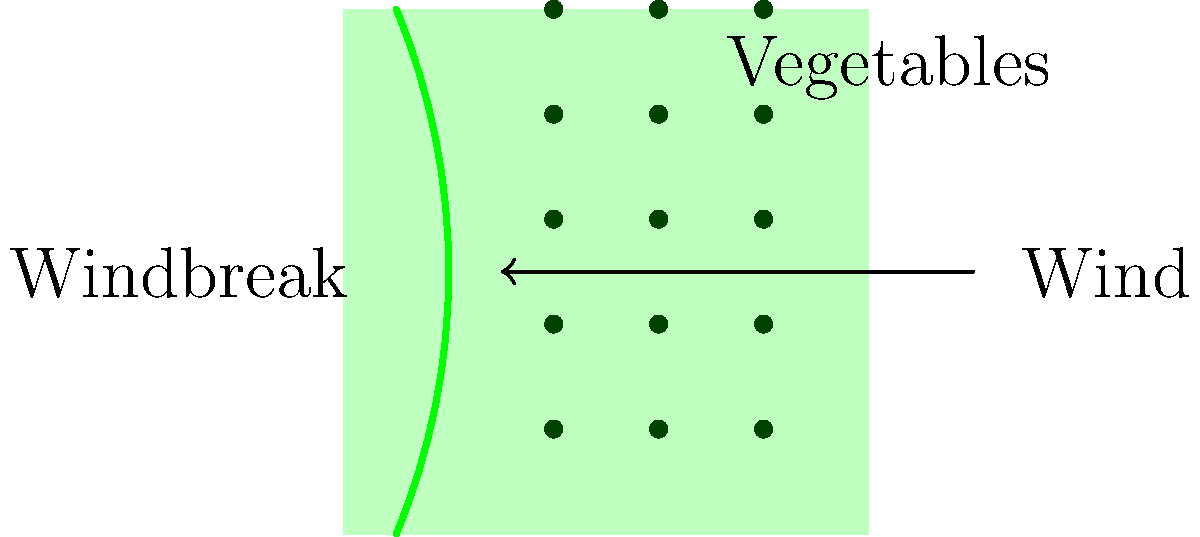In the diagram, a windbreak of flowering shrubs is shown protecting a vegetable field. If the dominant wind direction is from right to left, what is the most effective shape for the windbreak to maximize protection for the vegetables? To determine the most effective shape for the windbreak, we need to consider several factors:

1. Wind deflection: The primary purpose of a windbreak is to deflect wind upwards and over the protected area.

2. Porosity: An effective windbreak should be semi-permeable, allowing some wind to pass through while reducing overall wind speed.

3. Height: The taller the windbreak, the larger the protected area behind it.

4. Length: The windbreak should extend beyond the area to be protected to prevent wind from wrapping around the ends.

5. Curvature: A slight curve in the windbreak can help to diffuse wind energy more effectively than a straight line.

Considering these factors, the most effective shape for the windbreak would be a curved or slightly concave shape facing the wind. This shape:

a) Deflects wind upwards more effectively than a straight line.
b) Provides a larger protected area behind the windbreak.
c) Reduces turbulence at the edges of the protected area.
d) Allows for some wind penetration, which is beneficial for plant pollination and prevents stagnant air.

The curve shown in the diagram, bowing slightly towards the wind source, represents this optimal shape for maximum protection of the vegetable crops.
Answer: Curved or slightly concave facing the wind 